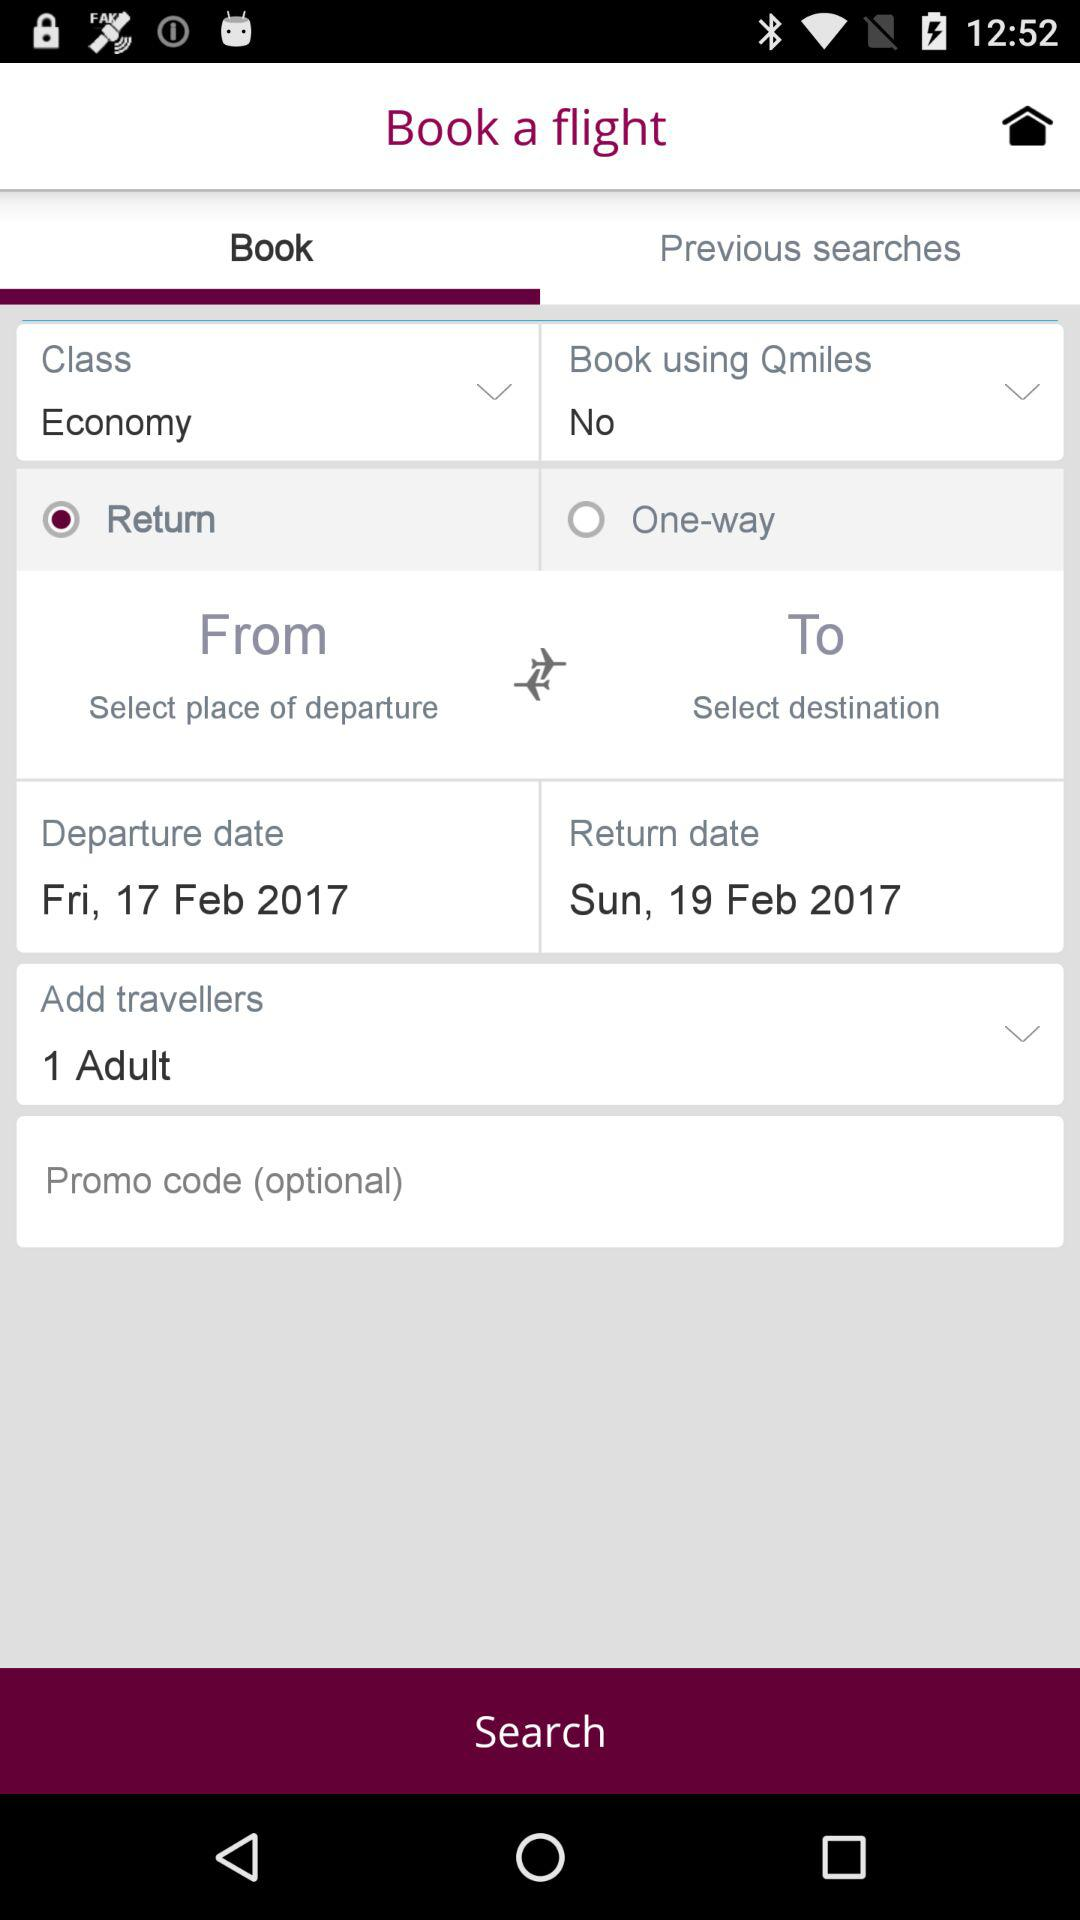Which class is booked for the flight? The booked class for the flight is economy. 